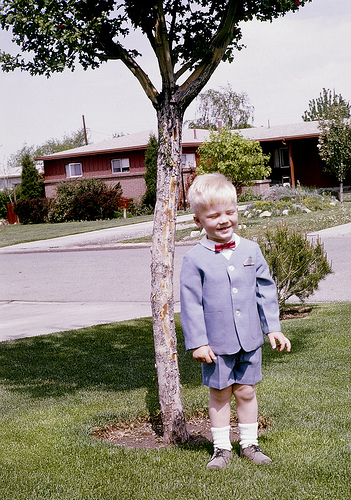<image>
Is the child behind the tree? Yes. From this viewpoint, the child is positioned behind the tree, with the tree partially or fully occluding the child. 